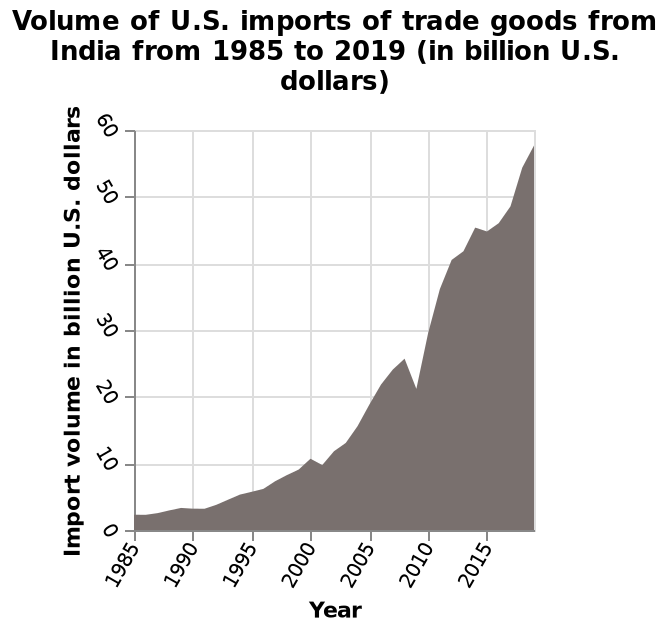<image>
What was the trend in U.S. imports of trade goods from India from 1985 to 2009? The trend in U.S. imports of trade goods from India from 1985 to 2009 was generally increasing, with a small drop in 2009. please summary the statistics and relations of the chart The area graph shows positive correaltion increasing from 2 in 1985 to 57 in 2020. 